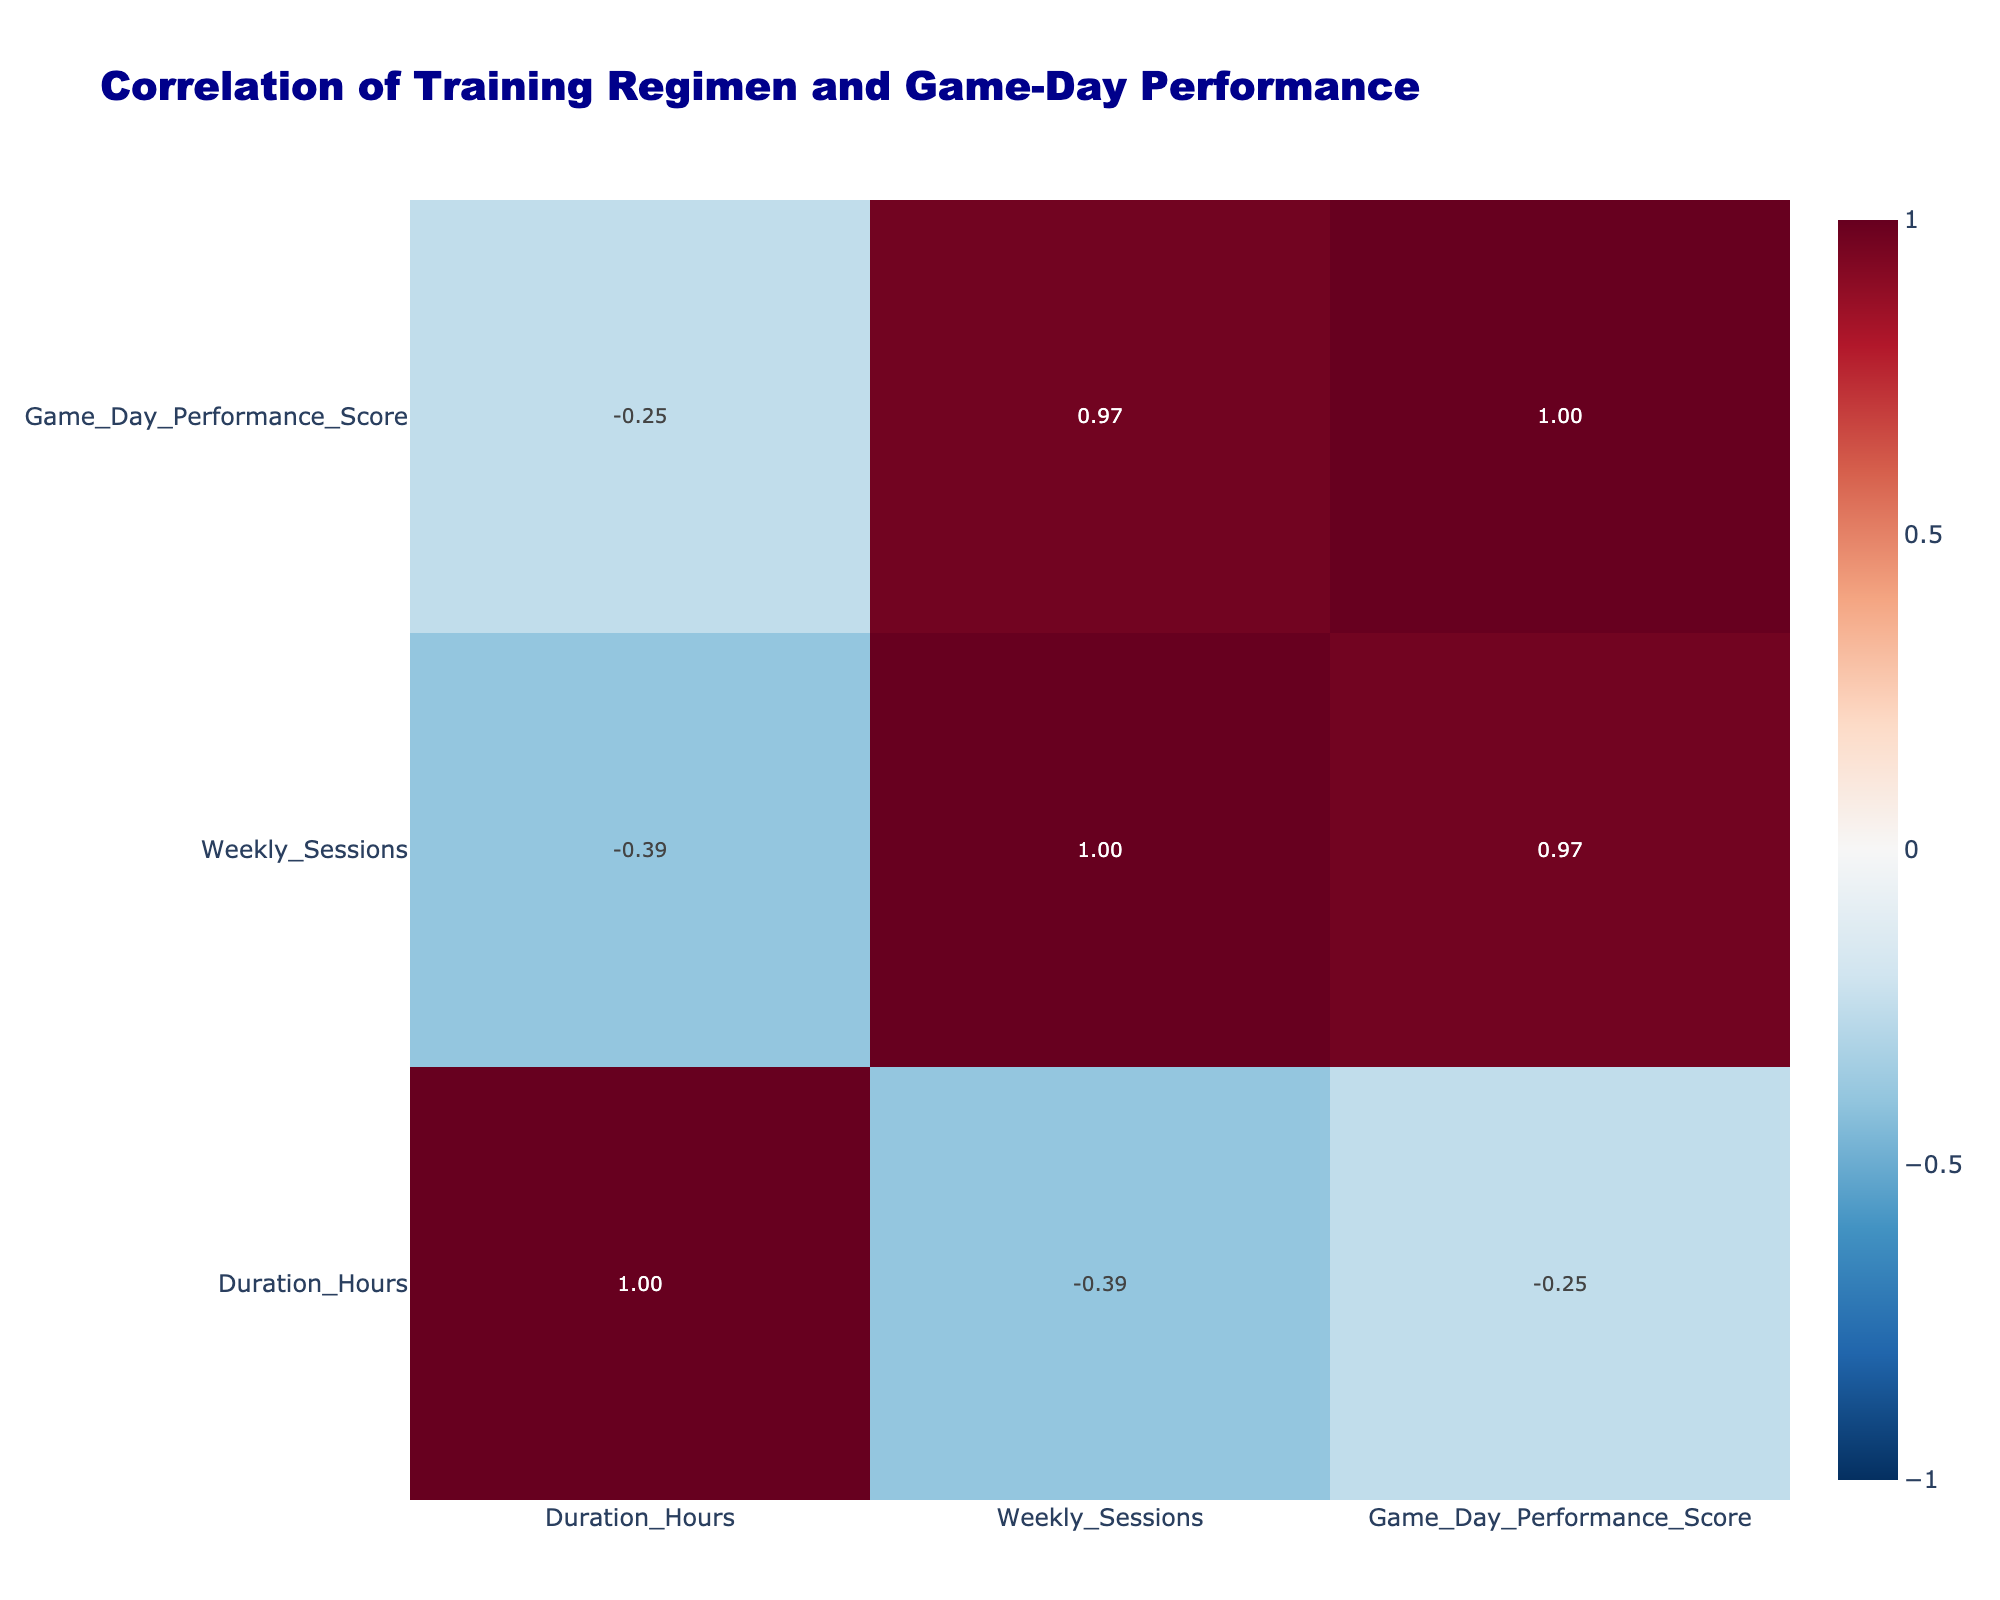What is the Game Day Performance Score for Speed Drills? The corresponding row for Speed Drills shows a Game Day Performance Score of 90, which can be directly referenced from the table.
Answer: 90 What correlation exists between Conditioning Sprints and Game Day Performance Score? By examining the table, the correlation value for Conditioning Sprints is 0.43 with respect to Game Day Performance Score, indicating a moderate positive correlation.
Answer: 0.43 Is there a positive correlation between Strength Training and Muscle Strength? The correlation value between these two variables is 0.75, which indicates a strong positive correlation. Therefore, the statement is true.
Answer: Yes What is the average Game Day Performance Score for regimens involving a medium intensity level? The scores for Medium intensity are: 90 (Speed Drills) + 78 (Endurance Training) + 88 (Mental Preparation) + 87 (Position Specific Practice) = 343. There are 4 scores, so the average is 343 / 4 = 85.75.
Answer: 85.75 Which training regimen has the lowest Game Day Performance Score? Checking the Game Day Performance Scores, Recovery Sessions have the lowest score of 70, making it the least effective regimen based on this measure.
Answer: 70 What is the difference in Game Day Performance Score between Mobility Work and Endurance Training? Mobility Work has a score of 80 and Endurance Training has a score of 78. The difference is calculated by subtracting the two scores: 80 - 78 = 2.
Answer: 2 Does Game Day Performance Score have a negative correlation with Nutrition Monitoring? The correlation value between Nutrition Monitoring and Game Day Performance Score is -0.68, indicating a substantial negative correlation. Therefore, the statement is true.
Answer: Yes What is the total duration in hours for the training regimens with a Game Day Performance Score above 85? The regimens with scores above 85 are Strength Training (2 hours), Speed Drills (1.5 hours), Game Tape Review (1 hour), Mental Preparation (1 hour), and Position Specific Practice (2 hours). Adding them yields 2 + 1.5 + 1 + 1 + 2 = 7.5 hours.
Answer: 7.5 hours 